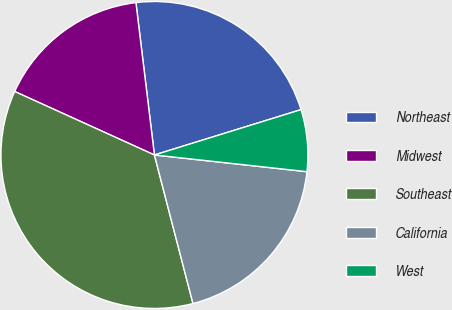Convert chart. <chart><loc_0><loc_0><loc_500><loc_500><pie_chart><fcel>Northeast<fcel>Midwest<fcel>Southeast<fcel>California<fcel>West<nl><fcel>22.15%<fcel>16.29%<fcel>35.83%<fcel>19.22%<fcel>6.51%<nl></chart> 